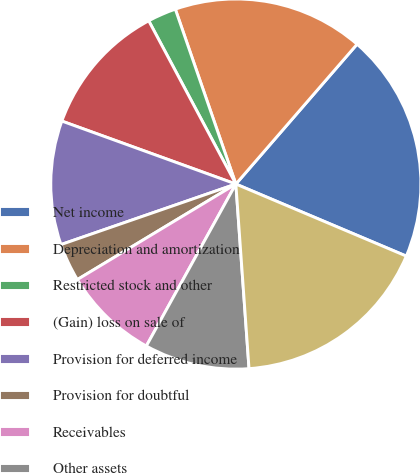<chart> <loc_0><loc_0><loc_500><loc_500><pie_chart><fcel>Net income<fcel>Depreciation and amortization<fcel>Restricted stock and other<fcel>(Gain) loss on sale of<fcel>Provision for deferred income<fcel>Provision for doubtful<fcel>Receivables<fcel>Other assets<fcel>Medical and other expenses<nl><fcel>20.0%<fcel>16.67%<fcel>2.5%<fcel>11.67%<fcel>10.83%<fcel>3.33%<fcel>8.33%<fcel>9.17%<fcel>17.5%<nl></chart> 